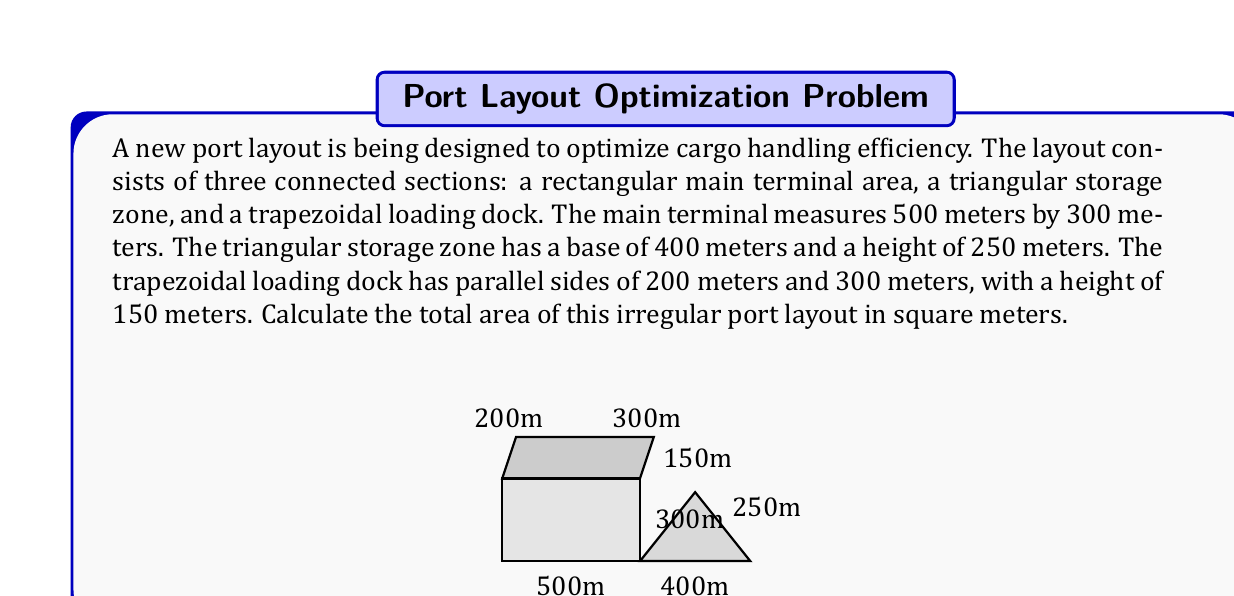Help me with this question. To calculate the total area of the irregular port layout, we need to sum the areas of the three sections:

1. Rectangular main terminal:
   Area = length × width
   $A_r = 500 \text{ m} \times 300 \text{ m} = 150,000 \text{ m}^2$

2. Triangular storage zone:
   Area = $\frac{1}{2} \times$ base × height
   $A_t = \frac{1}{2} \times 400 \text{ m} \times 250 \text{ m} = 50,000 \text{ m}^2$

3. Trapezoidal loading dock:
   Area = $\frac{1}{2} \times$ (sum of parallel sides) × height
   $A_p = \frac{1}{2} \times (200 \text{ m} + 300 \text{ m}) \times 150 \text{ m} = 37,500 \text{ m}^2$

Total area:
$$A_{total} = A_r + A_t + A_p$$
$$A_{total} = 150,000 \text{ m}^2 + 50,000 \text{ m}^2 + 37,500 \text{ m}^2 = 237,500 \text{ m}^2$$
Answer: 237,500 m² 